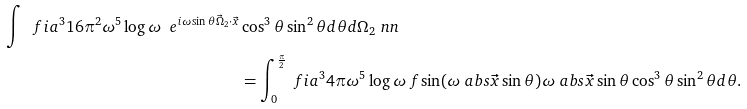Convert formula to latex. <formula><loc_0><loc_0><loc_500><loc_500>\int \ f { i a ^ { 3 } } { 1 6 \pi ^ { 2 } } \omega ^ { 5 } \log \omega \ e ^ { i \omega \sin \theta \vec { \Omega } _ { 2 } \cdot \vec { x } } & \cos ^ { 3 } \theta \sin ^ { 2 } \theta d \theta d \Omega _ { 2 } \ n n \\ & = \int _ { 0 } ^ { \frac { \pi } { 2 } } \ f { i a ^ { 3 } } { 4 \pi } \omega ^ { 5 } \log \omega \ f { \sin ( \omega \ a b s { \vec { x } } \sin \theta ) } { \omega \ a b s { \vec { x } } \sin \theta } \cos ^ { 3 } \theta \sin ^ { 2 } \theta d \theta .</formula> 